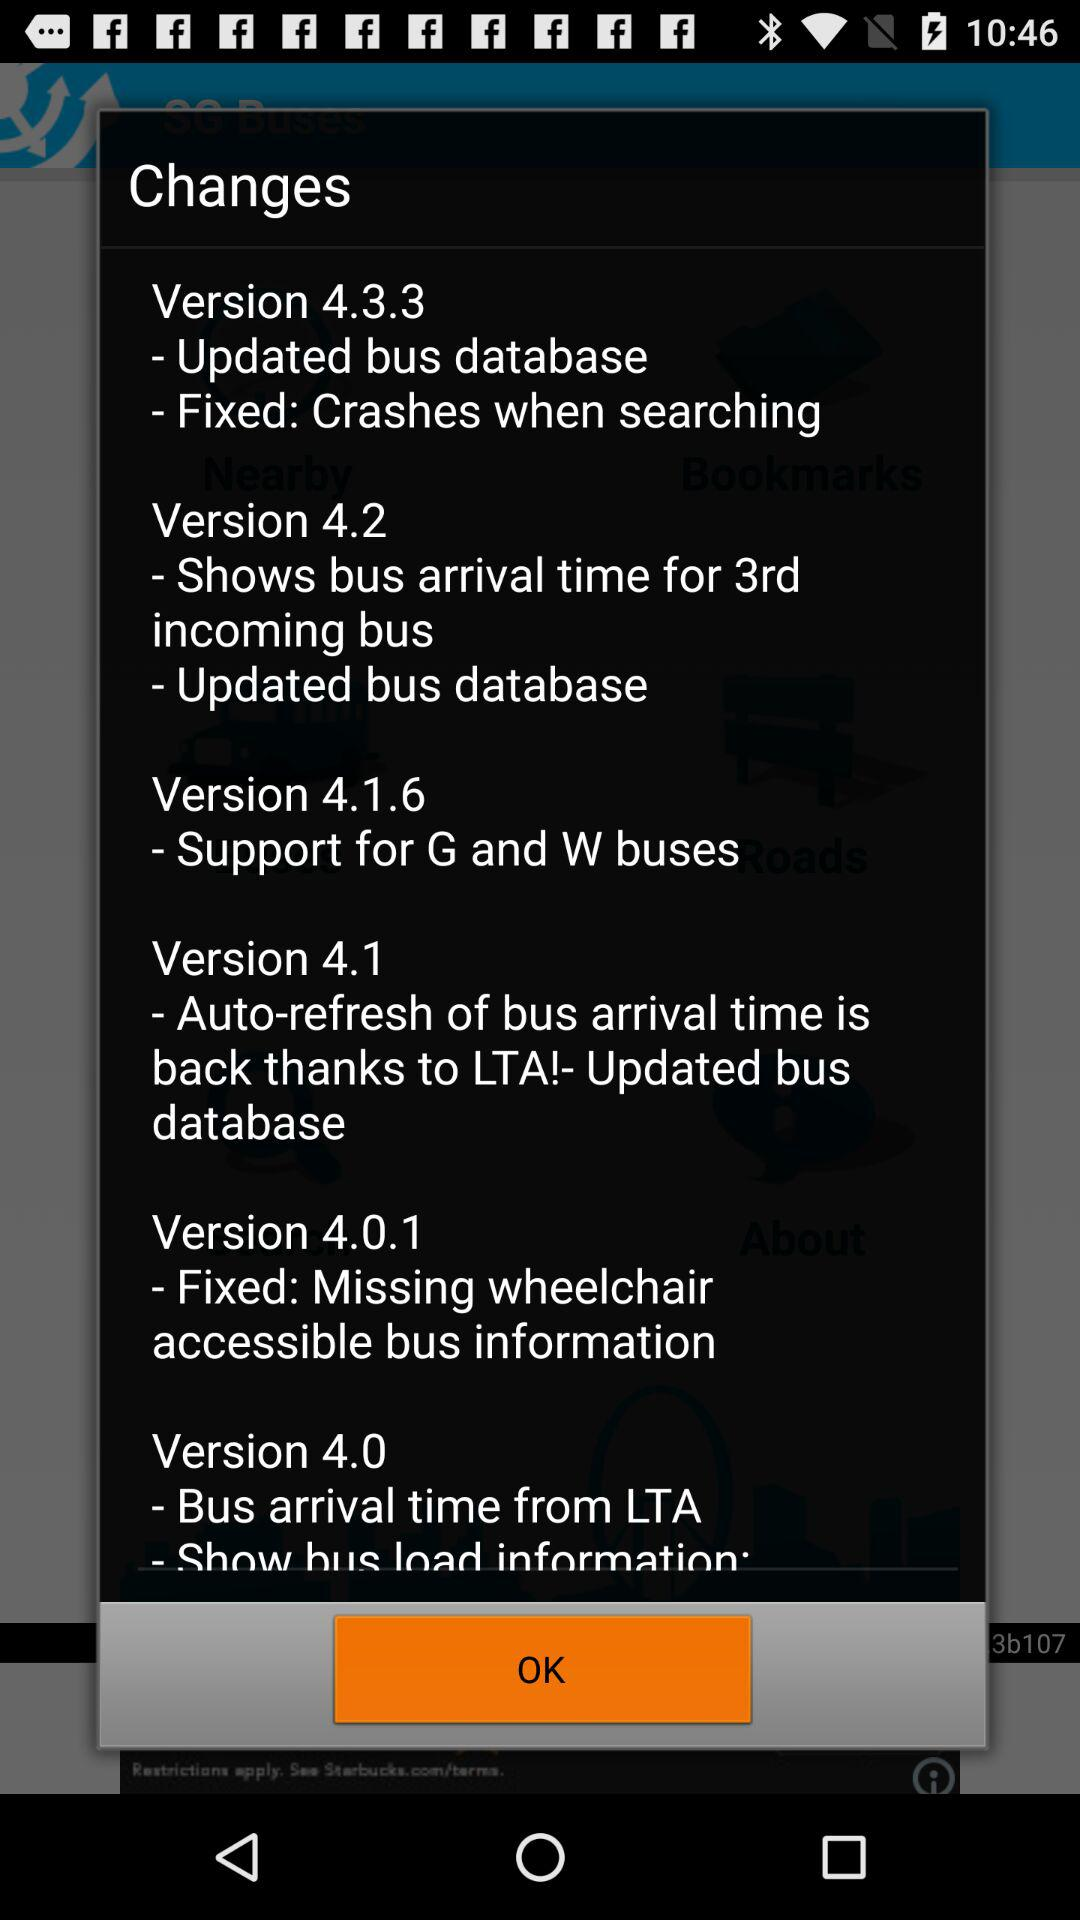What are the updates for version 4.1? The update for version 4.1 is "- Auto-refresh of bus arrival time is back thanks to LTA!- Updated bus database". 